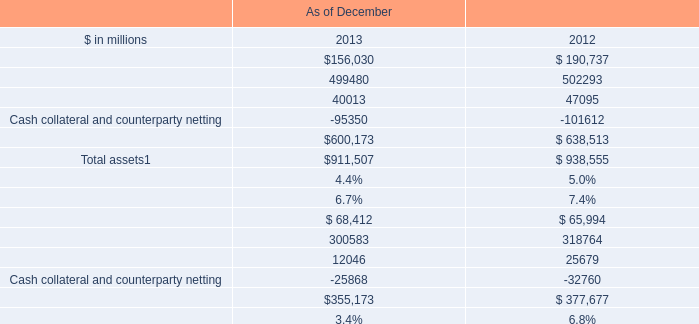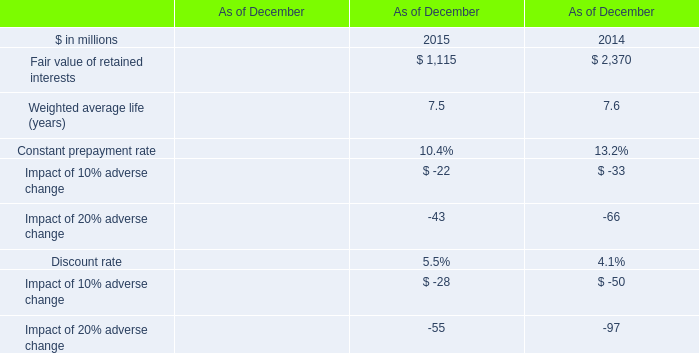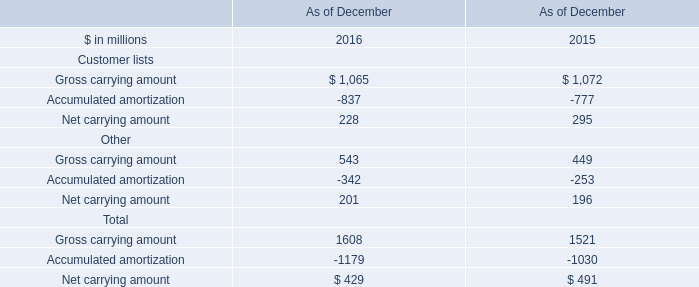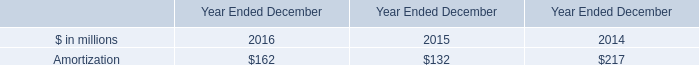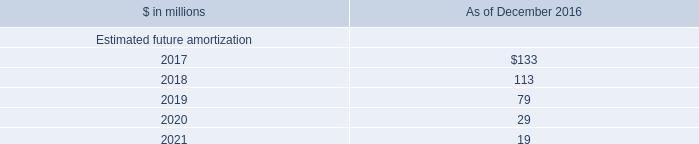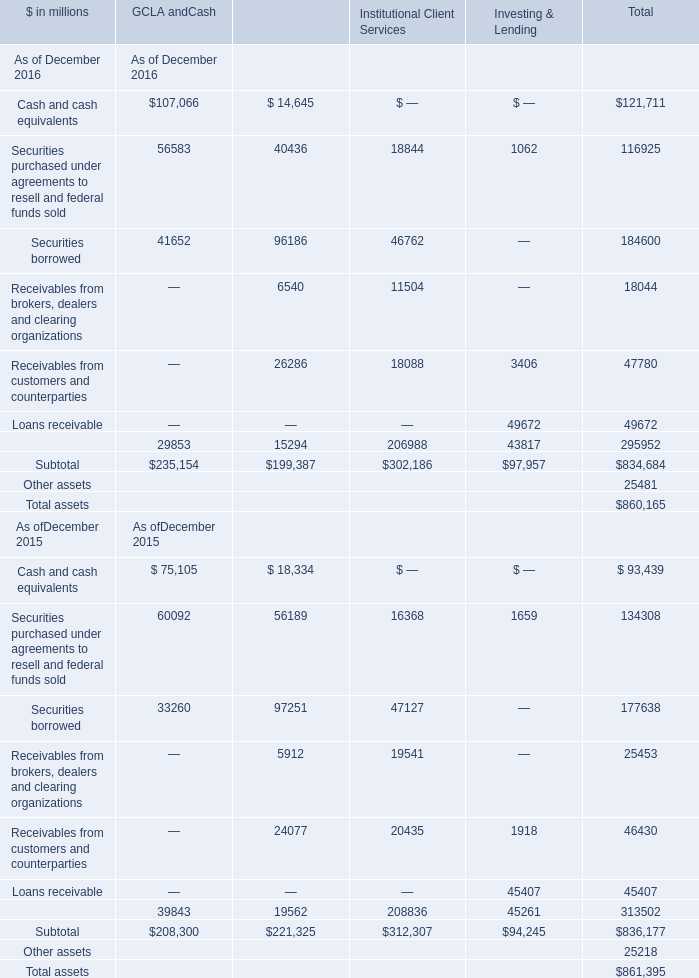What is the total amount of Cash collateral and counterparty netting of As of December 2012, and Securities borrowed of Institutional Client Services ? 
Computations: (101612.0 + 46762.0)
Answer: 148374.0. 